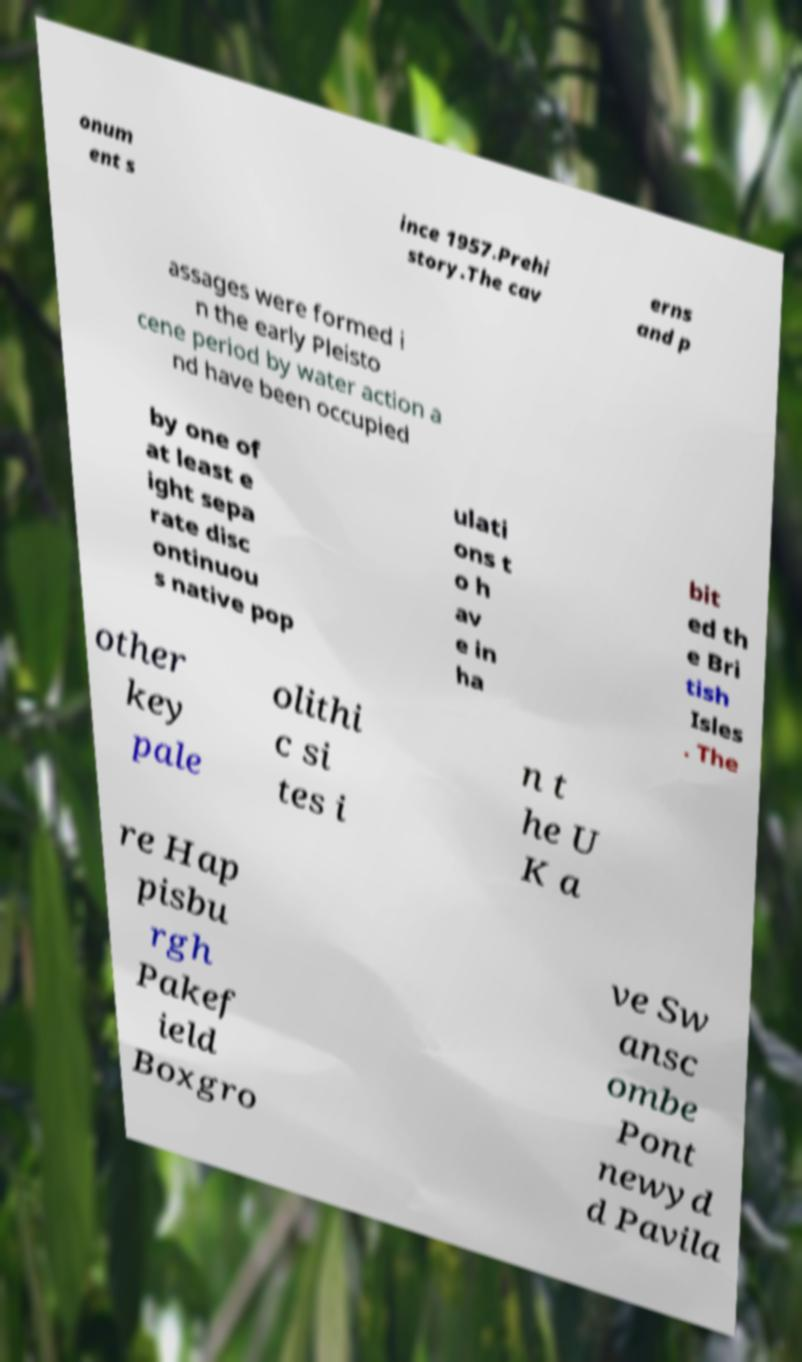What messages or text are displayed in this image? I need them in a readable, typed format. onum ent s ince 1957.Prehi story.The cav erns and p assages were formed i n the early Pleisto cene period by water action a nd have been occupied by one of at least e ight sepa rate disc ontinuou s native pop ulati ons t o h av e in ha bit ed th e Bri tish Isles . The other key pale olithi c si tes i n t he U K a re Hap pisbu rgh Pakef ield Boxgro ve Sw ansc ombe Pont newyd d Pavila 